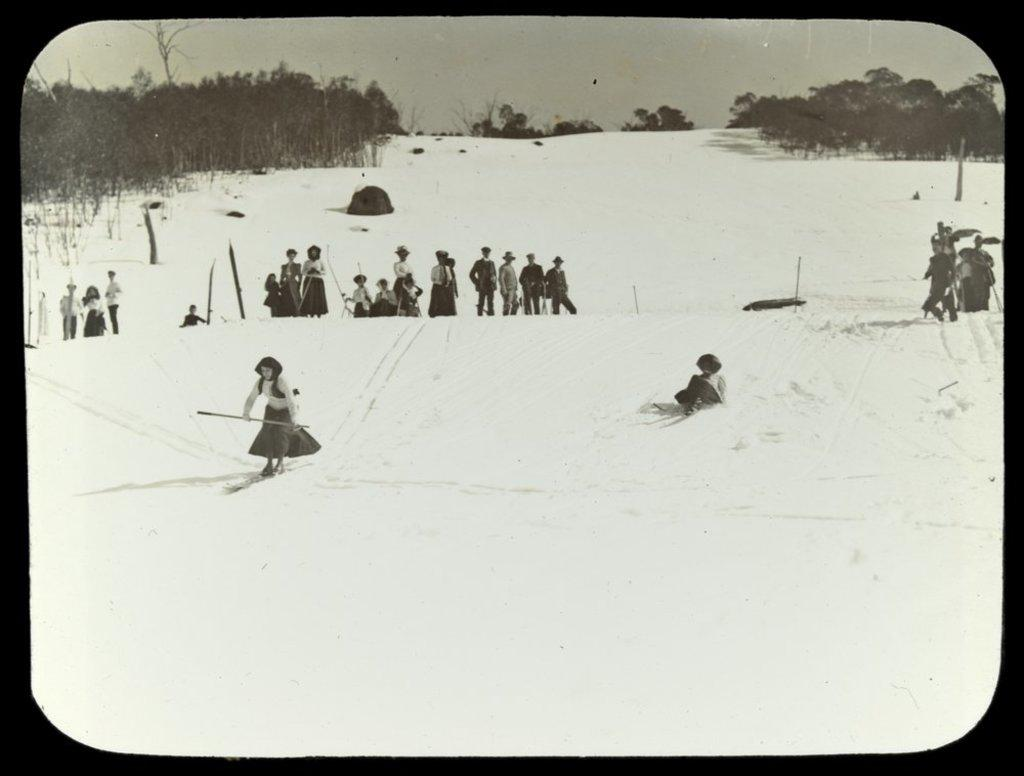What is the color scheme of the image? The image is black and white. What are the persons in the image doing? The persons are on a snowy surface in the middle of the image. What can be seen in the background of the image? There are trees and clouds in the sky in the background of the image. What type of substance is being used by the persons in the image to enjoy the summer season? The image does not depict a summer season, and there is no substance mentioned or visible in the image. 